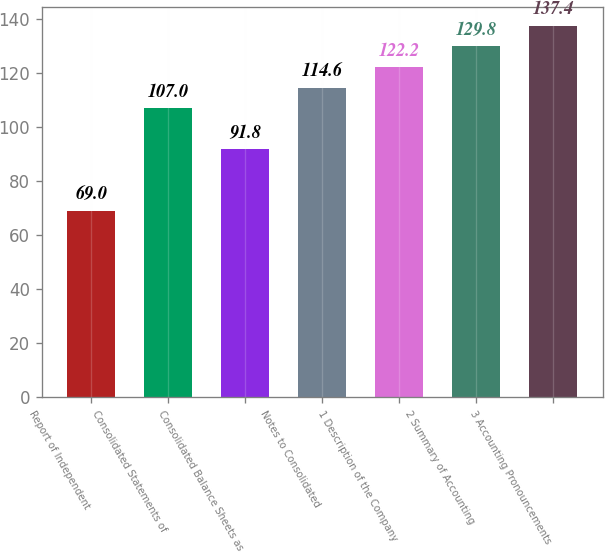Convert chart to OTSL. <chart><loc_0><loc_0><loc_500><loc_500><bar_chart><fcel>Report of Independent<fcel>Consolidated Statements of<fcel>Consolidated Balance Sheets as<fcel>Notes to Consolidated<fcel>1 Description of the Company<fcel>2 Summary of Accounting<fcel>3 Accounting Pronouncements<nl><fcel>69<fcel>107<fcel>91.8<fcel>114.6<fcel>122.2<fcel>129.8<fcel>137.4<nl></chart> 